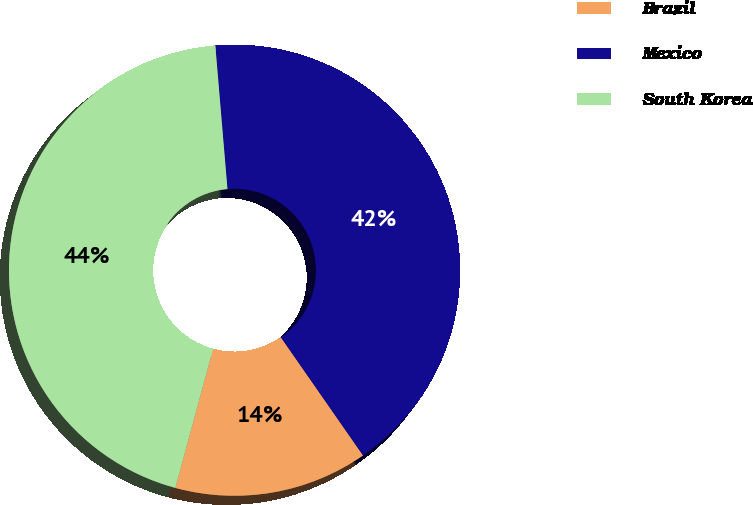Convert chart to OTSL. <chart><loc_0><loc_0><loc_500><loc_500><pie_chart><fcel>Brazil<fcel>Mexico<fcel>South Korea<nl><fcel>13.89%<fcel>41.67%<fcel>44.44%<nl></chart> 